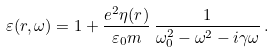<formula> <loc_0><loc_0><loc_500><loc_500>\varepsilon ( r , \omega ) = 1 + \frac { e ^ { 2 } \eta ( r ) } { \varepsilon _ { 0 } m } \, \frac { 1 } { \omega _ { 0 } ^ { 2 } - \omega ^ { 2 } - i \gamma \omega } \, .</formula> 